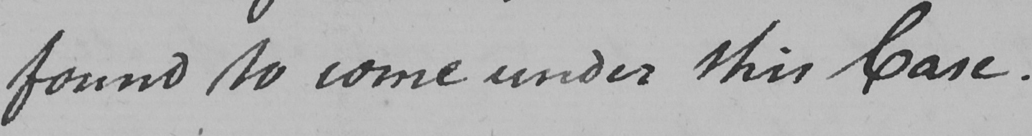Transcribe the text shown in this historical manuscript line. found to come under this Case . 